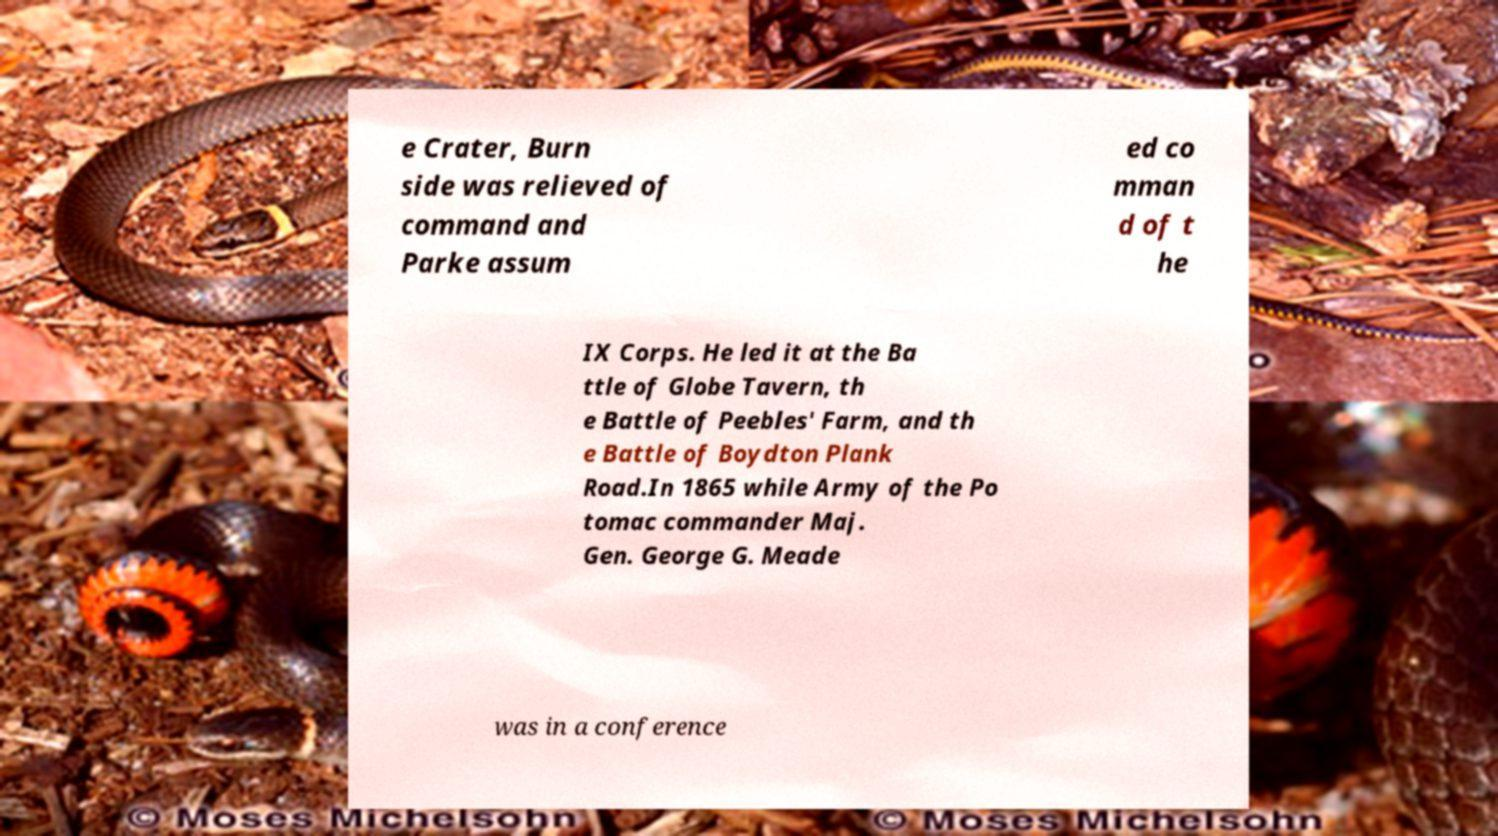Can you read and provide the text displayed in the image?This photo seems to have some interesting text. Can you extract and type it out for me? e Crater, Burn side was relieved of command and Parke assum ed co mman d of t he IX Corps. He led it at the Ba ttle of Globe Tavern, th e Battle of Peebles' Farm, and th e Battle of Boydton Plank Road.In 1865 while Army of the Po tomac commander Maj. Gen. George G. Meade was in a conference 